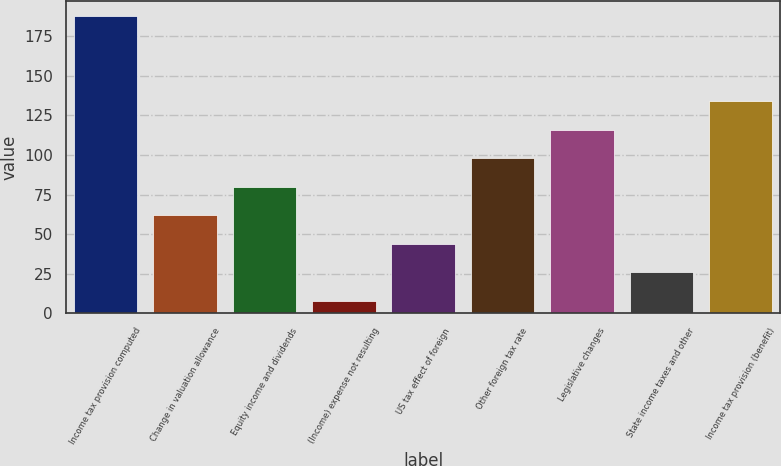<chart> <loc_0><loc_0><loc_500><loc_500><bar_chart><fcel>Income tax provision computed<fcel>Change in valuation allowance<fcel>Equity income and dividends<fcel>(Income) expense not resulting<fcel>US tax effect of foreign<fcel>Other foreign tax rate<fcel>Legislative changes<fcel>State income taxes and other<fcel>Income tax provision (benefit)<nl><fcel>188<fcel>62<fcel>80<fcel>8<fcel>44<fcel>98<fcel>116<fcel>26<fcel>134<nl></chart> 